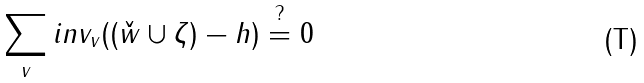Convert formula to latex. <formula><loc_0><loc_0><loc_500><loc_500>\sum _ { v } i n v _ { v } ( ( \check { w } \cup \zeta ) - h ) \stackrel { ? } { = } 0</formula> 